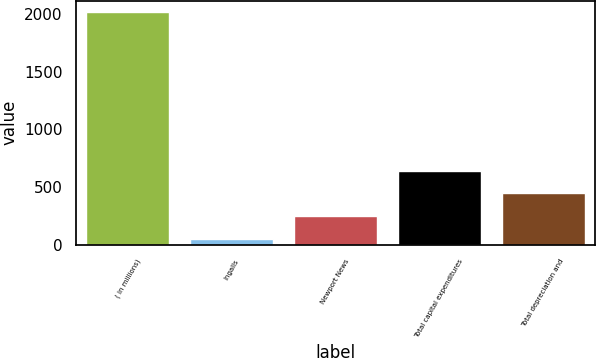Convert chart. <chart><loc_0><loc_0><loc_500><loc_500><bar_chart><fcel>( in millions)<fcel>Ingalls<fcel>Newport News<fcel>Total capital expenditures<fcel>Total depreciation and<nl><fcel>2015<fcel>53<fcel>249.2<fcel>641.6<fcel>445.4<nl></chart> 